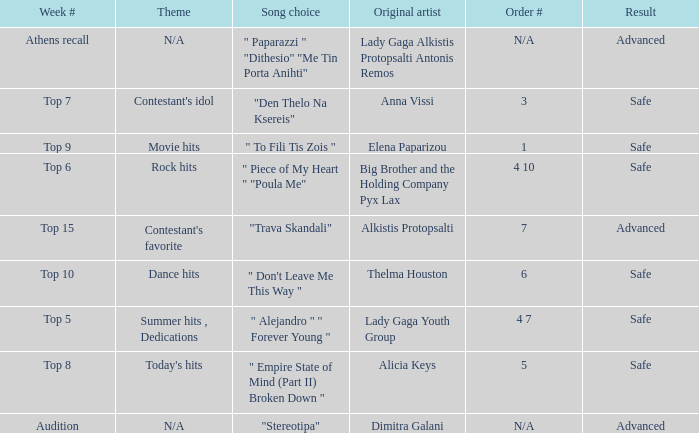Which artists have order # 1? Elena Paparizou. 